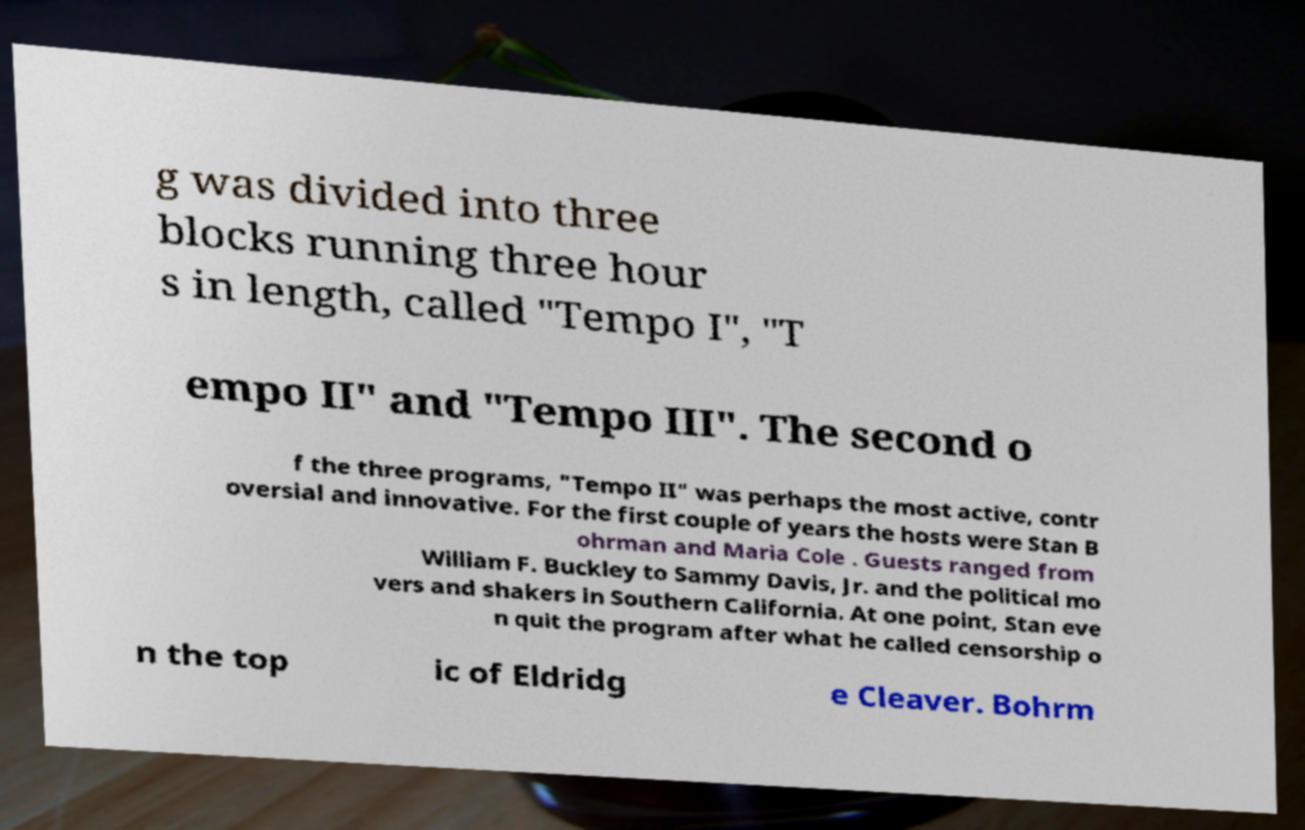What messages or text are displayed in this image? I need them in a readable, typed format. g was divided into three blocks running three hour s in length, called "Tempo I", "T empo II" and "Tempo III". The second o f the three programs, "Tempo II" was perhaps the most active, contr oversial and innovative. For the first couple of years the hosts were Stan B ohrman and Maria Cole . Guests ranged from William F. Buckley to Sammy Davis, Jr. and the political mo vers and shakers in Southern California. At one point, Stan eve n quit the program after what he called censorship o n the top ic of Eldridg e Cleaver. Bohrm 